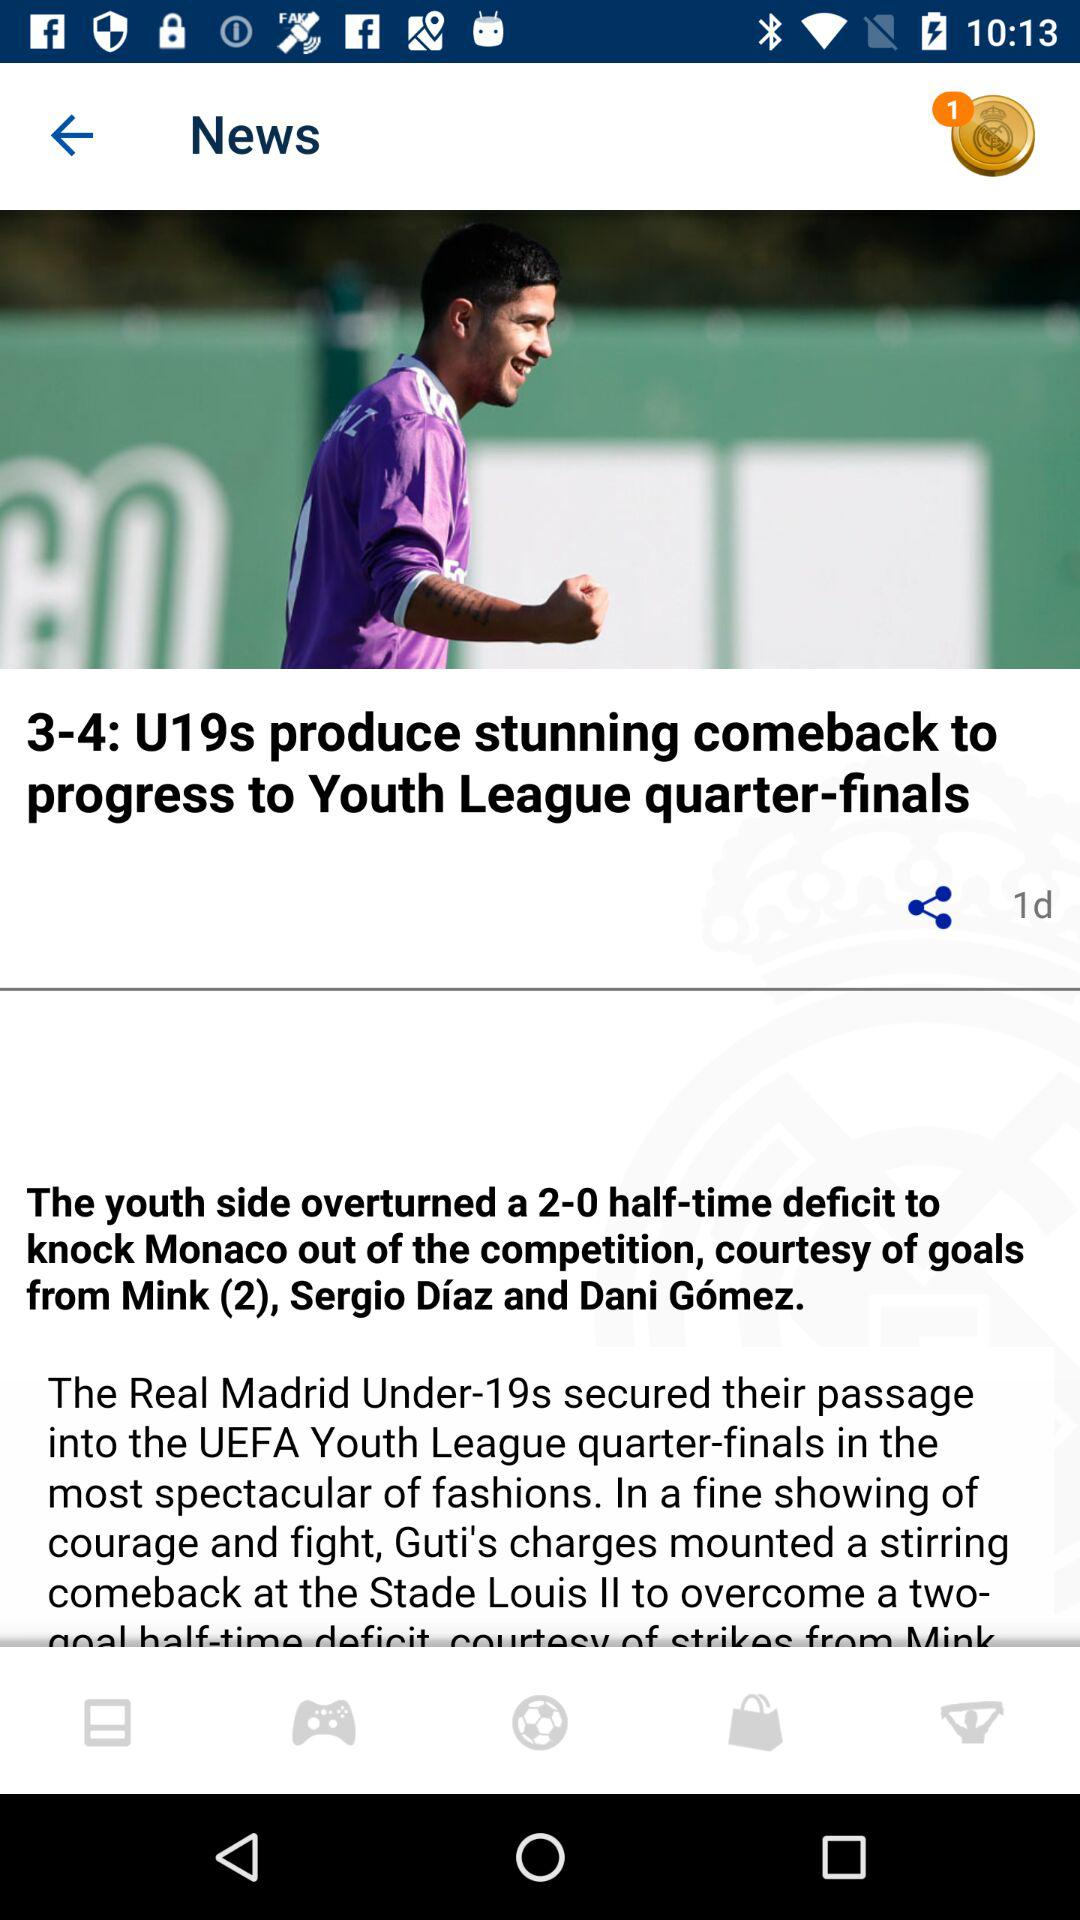How old is Sergio Díaz?
When the provided information is insufficient, respond with <no answer>. <no answer> 